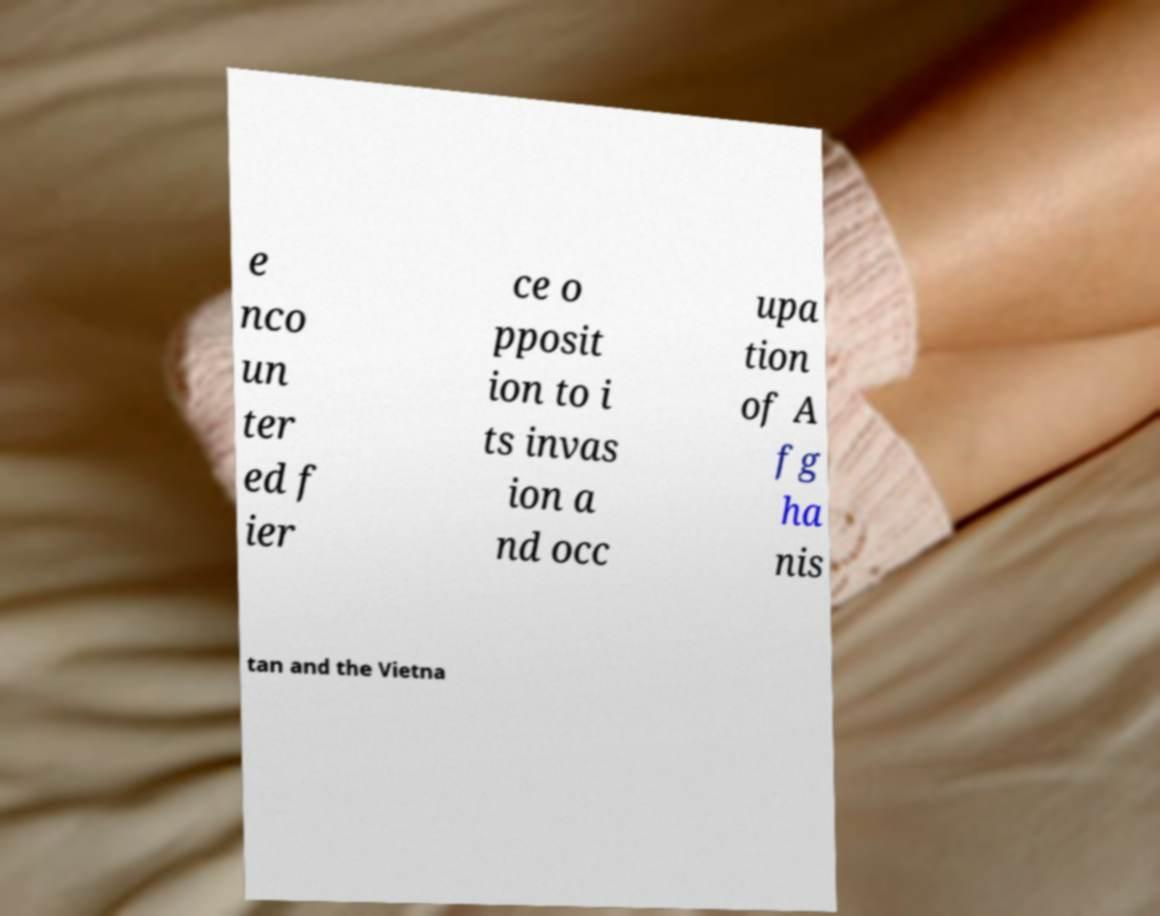For documentation purposes, I need the text within this image transcribed. Could you provide that? e nco un ter ed f ier ce o pposit ion to i ts invas ion a nd occ upa tion of A fg ha nis tan and the Vietna 